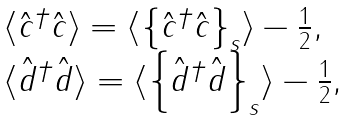Convert formula to latex. <formula><loc_0><loc_0><loc_500><loc_500>\begin{array} { l c l } \langle \hat { c } ^ { \dagger } \hat { c } \rangle = \langle \left \{ \hat { c } ^ { \dagger } \hat { c } \right \} _ { s } \rangle - \frac { 1 } { 2 } , \\ \langle \hat { d } ^ { \dagger } \hat { d } \rangle = \langle \left \{ \hat { d } ^ { \dagger } \hat { d } \right \} _ { s } \rangle - \frac { 1 } { 2 } , \end{array}</formula> 